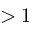Convert formula to latex. <formula><loc_0><loc_0><loc_500><loc_500>> 1</formula> 